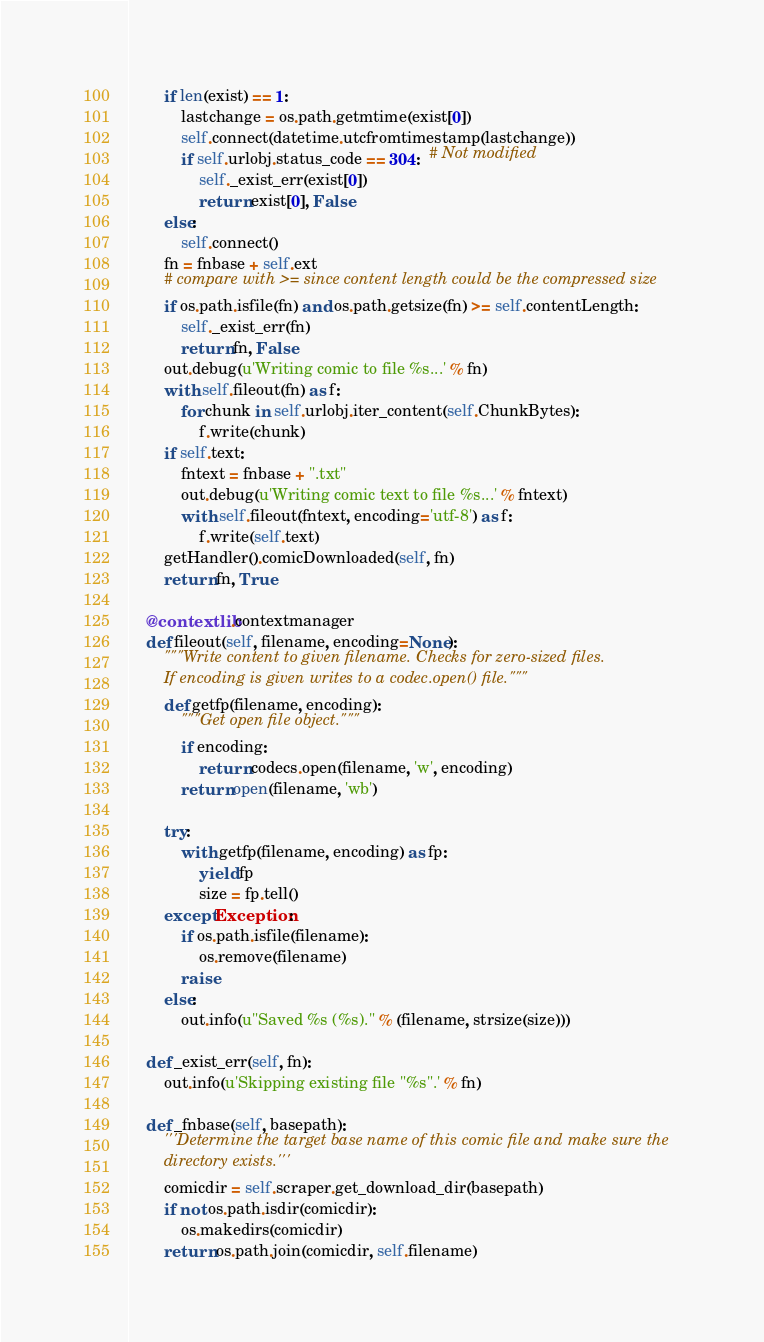Convert code to text. <code><loc_0><loc_0><loc_500><loc_500><_Python_>        if len(exist) == 1:
            lastchange = os.path.getmtime(exist[0])
            self.connect(datetime.utcfromtimestamp(lastchange))
            if self.urlobj.status_code == 304:  # Not modified
                self._exist_err(exist[0])
                return exist[0], False
        else:
            self.connect()
        fn = fnbase + self.ext
        # compare with >= since content length could be the compressed size
        if os.path.isfile(fn) and os.path.getsize(fn) >= self.contentLength:
            self._exist_err(fn)
            return fn, False
        out.debug(u'Writing comic to file %s...' % fn)
        with self.fileout(fn) as f:
            for chunk in self.urlobj.iter_content(self.ChunkBytes):
                f.write(chunk)
        if self.text:
            fntext = fnbase + ".txt"
            out.debug(u'Writing comic text to file %s...' % fntext)
            with self.fileout(fntext, encoding='utf-8') as f:
                f.write(self.text)
        getHandler().comicDownloaded(self, fn)
        return fn, True

    @contextlib.contextmanager
    def fileout(self, filename, encoding=None):
        """Write content to given filename. Checks for zero-sized files.
        If encoding is given writes to a codec.open() file."""
        def getfp(filename, encoding):
            """Get open file object."""
            if encoding:
                return codecs.open(filename, 'w', encoding)
            return open(filename, 'wb')

        try:
            with getfp(filename, encoding) as fp:
                yield fp
                size = fp.tell()
        except Exception:
            if os.path.isfile(filename):
                os.remove(filename)
            raise
        else:
            out.info(u"Saved %s (%s)." % (filename, strsize(size)))

    def _exist_err(self, fn):
        out.info(u'Skipping existing file "%s".' % fn)

    def _fnbase(self, basepath):
        '''Determine the target base name of this comic file and make sure the
        directory exists.'''
        comicdir = self.scraper.get_download_dir(basepath)
        if not os.path.isdir(comicdir):
            os.makedirs(comicdir)
        return os.path.join(comicdir, self.filename)
</code> 